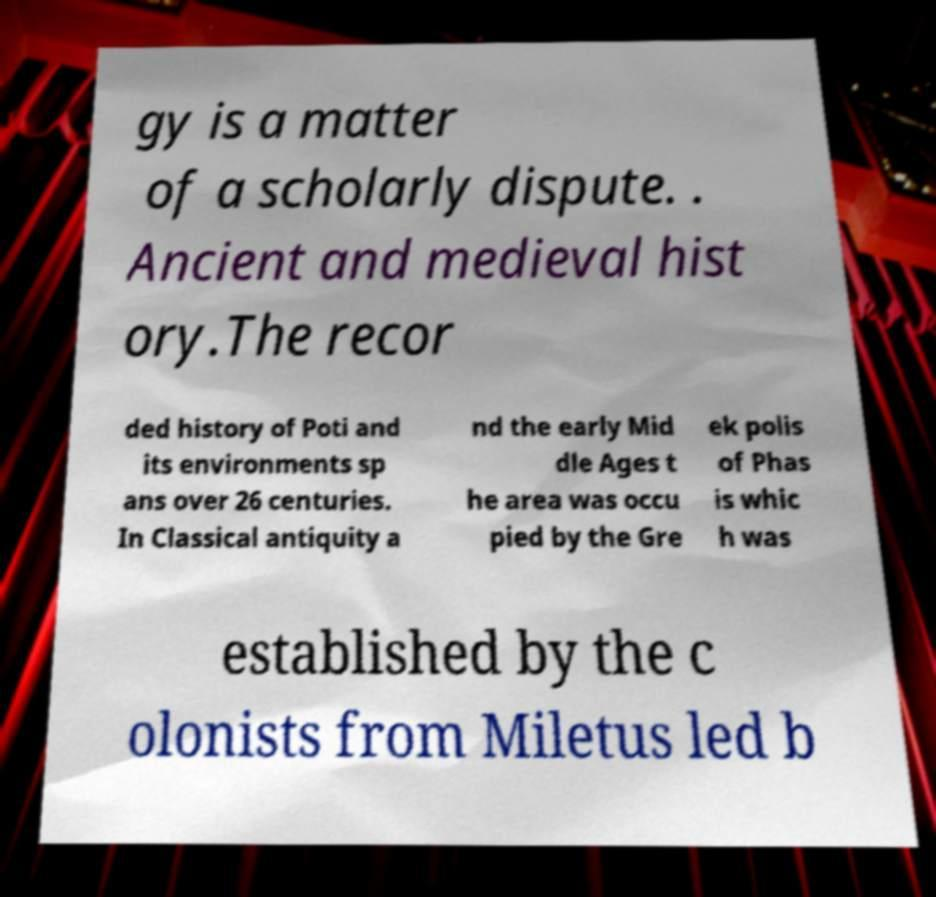There's text embedded in this image that I need extracted. Can you transcribe it verbatim? gy is a matter of a scholarly dispute. . Ancient and medieval hist ory.The recor ded history of Poti and its environments sp ans over 26 centuries. In Classical antiquity a nd the early Mid dle Ages t he area was occu pied by the Gre ek polis of Phas is whic h was established by the c olonists from Miletus led b 